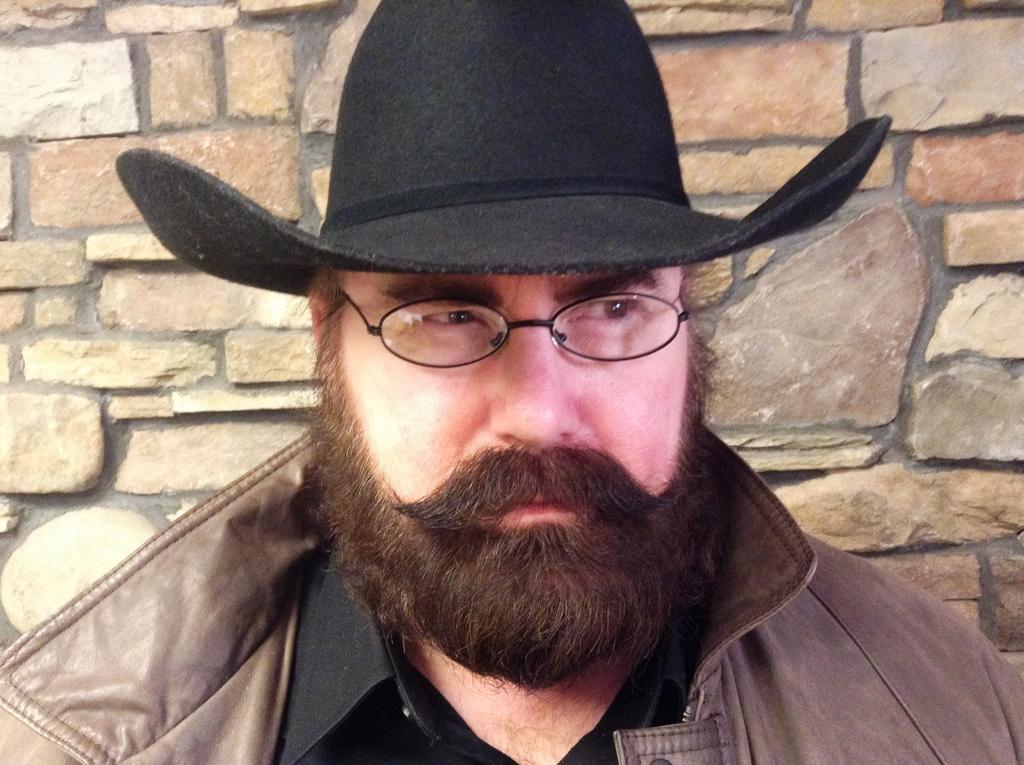What can be seen in the image? There is a person in the image. Can you describe the person's clothing? The person is wearing a brown and black color dress and a black cap. What is visible in the background of the image? There is a brick wall in the background of the image. What is the purpose of the furniture in the image? There is no furniture present in the image. Can you describe the taste of the person's clothing? The taste of the person's clothing is not relevant or observable in the image. 